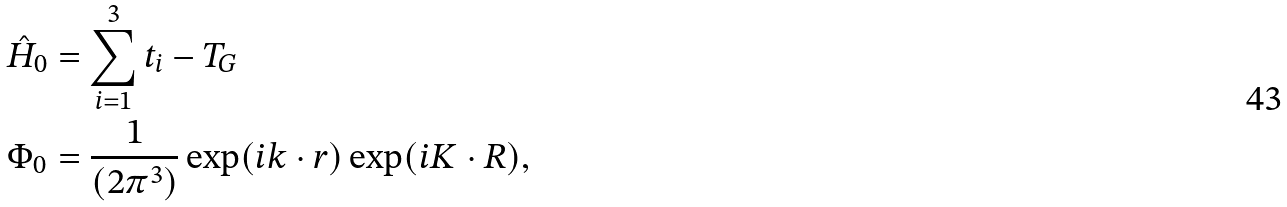<formula> <loc_0><loc_0><loc_500><loc_500>\hat { H } _ { 0 } & = \sum _ { i = 1 } ^ { 3 } t _ { i } - T _ { G } \\ \Phi _ { 0 } & = \frac { 1 } { ( 2 \pi ^ { 3 } ) } \exp ( i k \cdot r ) \exp ( i K \cdot R ) ,</formula> 